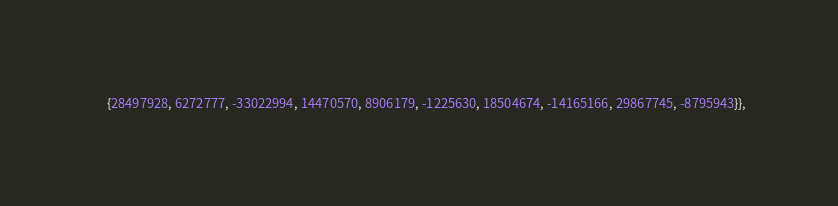<code> <loc_0><loc_0><loc_500><loc_500><_C_>     {28497928, 6272777, -33022994, 14470570, 8906179, -1225630, 18504674, -14165166, 29867745, -8795943}},</code> 